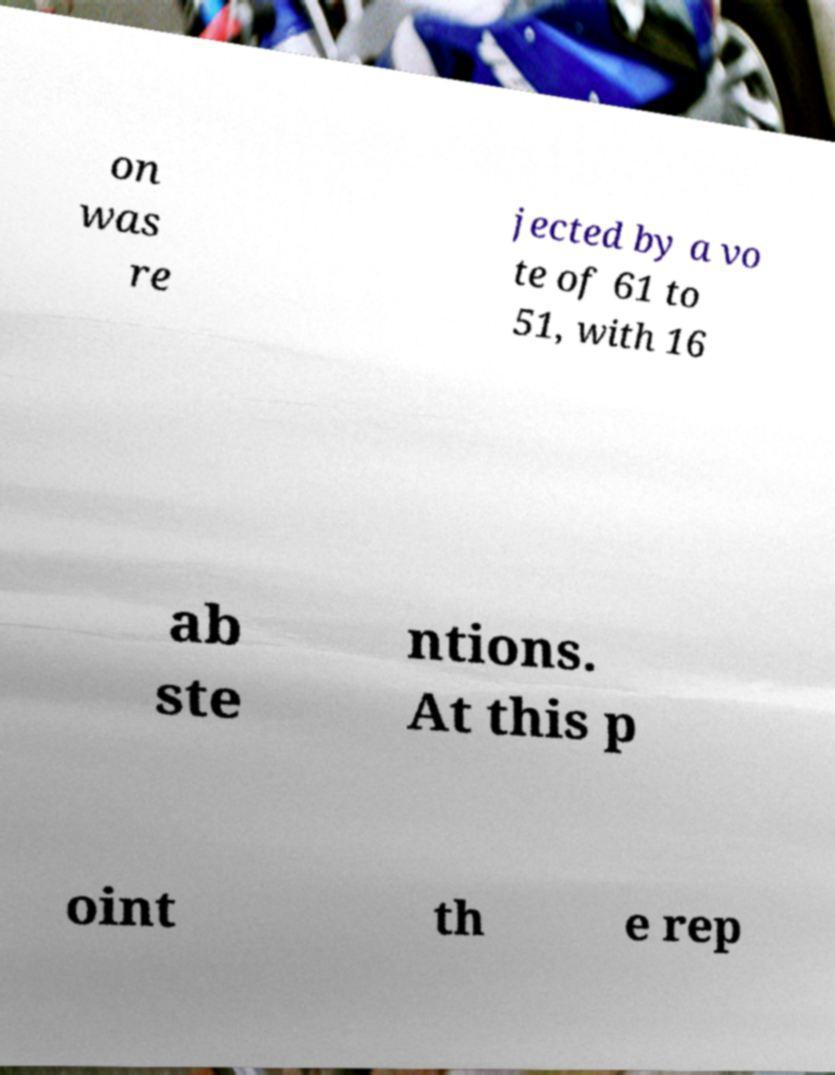I need the written content from this picture converted into text. Can you do that? on was re jected by a vo te of 61 to 51, with 16 ab ste ntions. At this p oint th e rep 